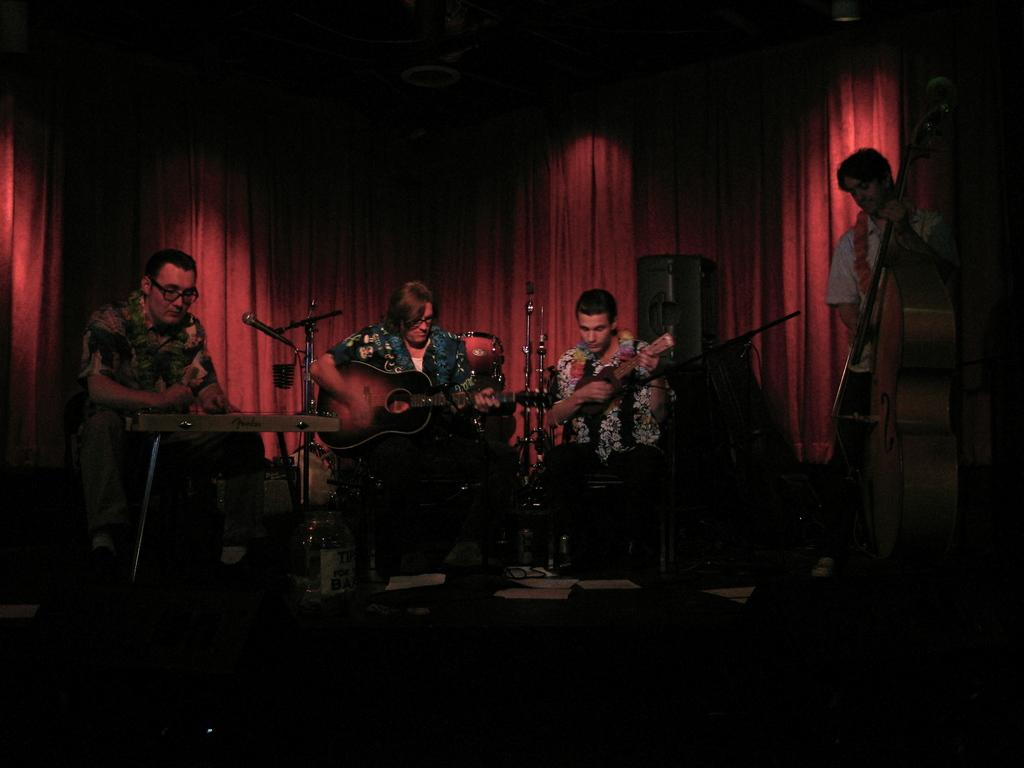How many people are on the stage in the image? There are four people on the stage in the image. What are the people on the stage doing? The people are performing. What activity are the performers engaged in? The people are playing musical instruments. What can be seen behind the performers on the stage? There is a cloth visible behind the performers. What type of metal is the collar made of that the performers are wearing in the image? There are no collars visible on the performers in the image, and therefore no metal type can be determined. 